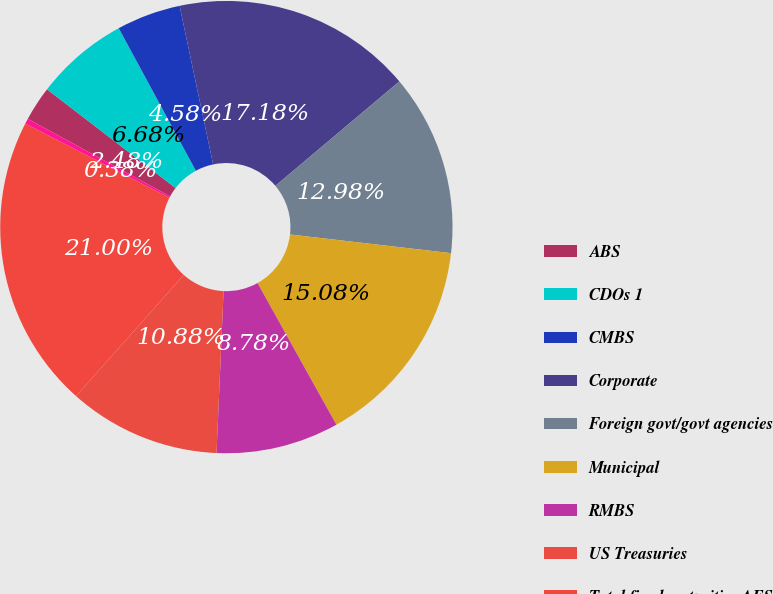Convert chart to OTSL. <chart><loc_0><loc_0><loc_500><loc_500><pie_chart><fcel>ABS<fcel>CDOs 1<fcel>CMBS<fcel>Corporate<fcel>Foreign govt/govt agencies<fcel>Municipal<fcel>RMBS<fcel>US Treasuries<fcel>Total fixed maturities AFS<fcel>Equity securities AFS<nl><fcel>2.48%<fcel>6.68%<fcel>4.58%<fcel>17.18%<fcel>12.98%<fcel>15.08%<fcel>8.78%<fcel>10.88%<fcel>21.0%<fcel>0.38%<nl></chart> 